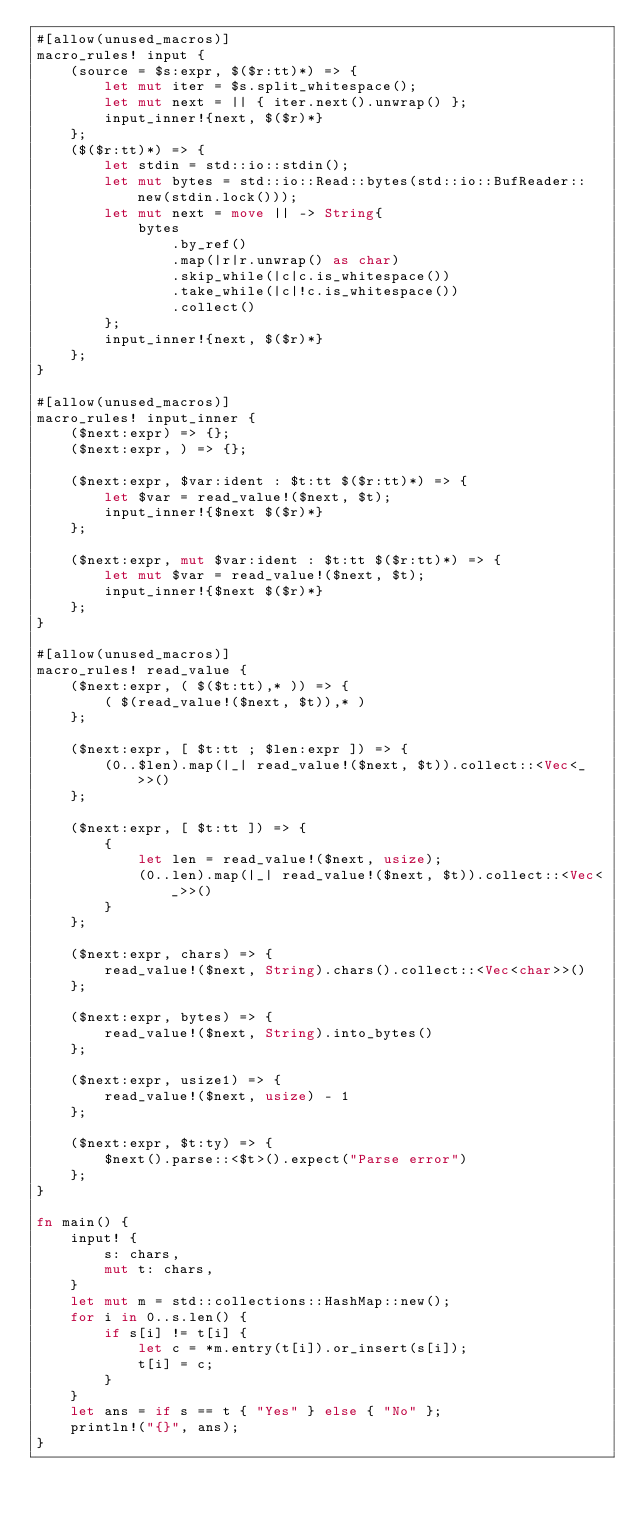Convert code to text. <code><loc_0><loc_0><loc_500><loc_500><_Rust_>#[allow(unused_macros)]
macro_rules! input {
    (source = $s:expr, $($r:tt)*) => {
        let mut iter = $s.split_whitespace();
        let mut next = || { iter.next().unwrap() };
        input_inner!{next, $($r)*}
    };
    ($($r:tt)*) => {
        let stdin = std::io::stdin();
        let mut bytes = std::io::Read::bytes(std::io::BufReader::new(stdin.lock()));
        let mut next = move || -> String{
            bytes
                .by_ref()
                .map(|r|r.unwrap() as char)
                .skip_while(|c|c.is_whitespace())
                .take_while(|c|!c.is_whitespace())
                .collect()
        };
        input_inner!{next, $($r)*}
    };
}

#[allow(unused_macros)]
macro_rules! input_inner {
    ($next:expr) => {};
    ($next:expr, ) => {};

    ($next:expr, $var:ident : $t:tt $($r:tt)*) => {
        let $var = read_value!($next, $t);
        input_inner!{$next $($r)*}
    };

    ($next:expr, mut $var:ident : $t:tt $($r:tt)*) => {
        let mut $var = read_value!($next, $t);
        input_inner!{$next $($r)*}
    };
}

#[allow(unused_macros)]
macro_rules! read_value {
    ($next:expr, ( $($t:tt),* )) => {
        ( $(read_value!($next, $t)),* )
    };

    ($next:expr, [ $t:tt ; $len:expr ]) => {
        (0..$len).map(|_| read_value!($next, $t)).collect::<Vec<_>>()
    };

    ($next:expr, [ $t:tt ]) => {
        {
            let len = read_value!($next, usize);
            (0..len).map(|_| read_value!($next, $t)).collect::<Vec<_>>()
        }
    };

    ($next:expr, chars) => {
        read_value!($next, String).chars().collect::<Vec<char>>()
    };

    ($next:expr, bytes) => {
        read_value!($next, String).into_bytes()
    };

    ($next:expr, usize1) => {
        read_value!($next, usize) - 1
    };

    ($next:expr, $t:ty) => {
        $next().parse::<$t>().expect("Parse error")
    };
}

fn main() {
    input! {
        s: chars,
        mut t: chars,
    }
    let mut m = std::collections::HashMap::new();
    for i in 0..s.len() {
        if s[i] != t[i] {
            let c = *m.entry(t[i]).or_insert(s[i]);
            t[i] = c;
        }
    }
    let ans = if s == t { "Yes" } else { "No" };
    println!("{}", ans);
}
</code> 